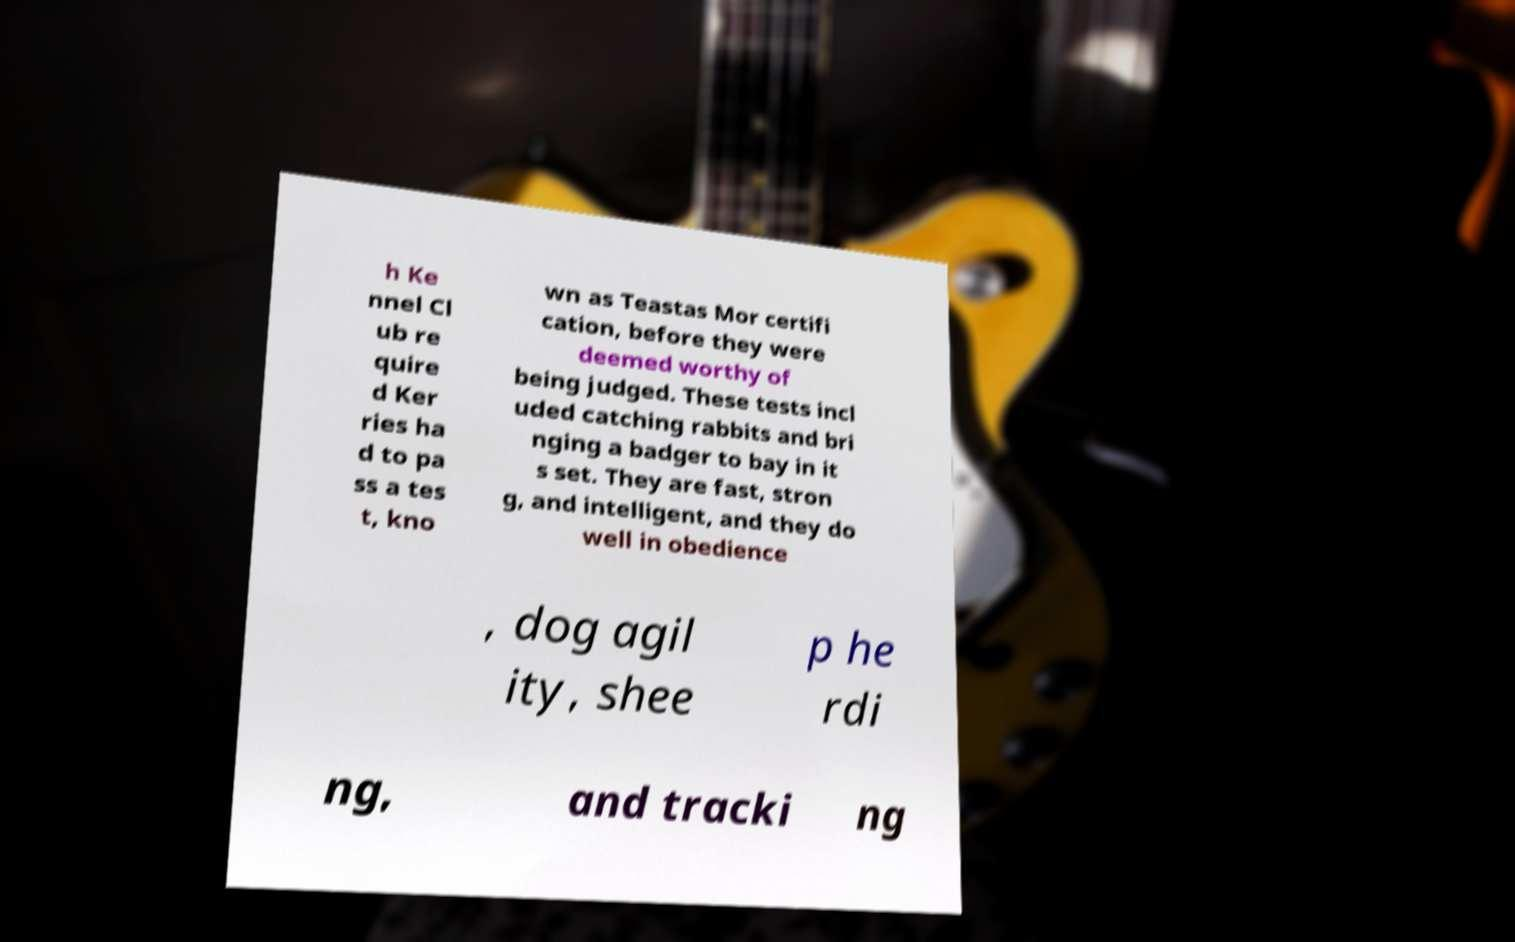For documentation purposes, I need the text within this image transcribed. Could you provide that? h Ke nnel Cl ub re quire d Ker ries ha d to pa ss a tes t, kno wn as Teastas Mor certifi cation, before they were deemed worthy of being judged. These tests incl uded catching rabbits and bri nging a badger to bay in it s set. They are fast, stron g, and intelligent, and they do well in obedience , dog agil ity, shee p he rdi ng, and tracki ng 